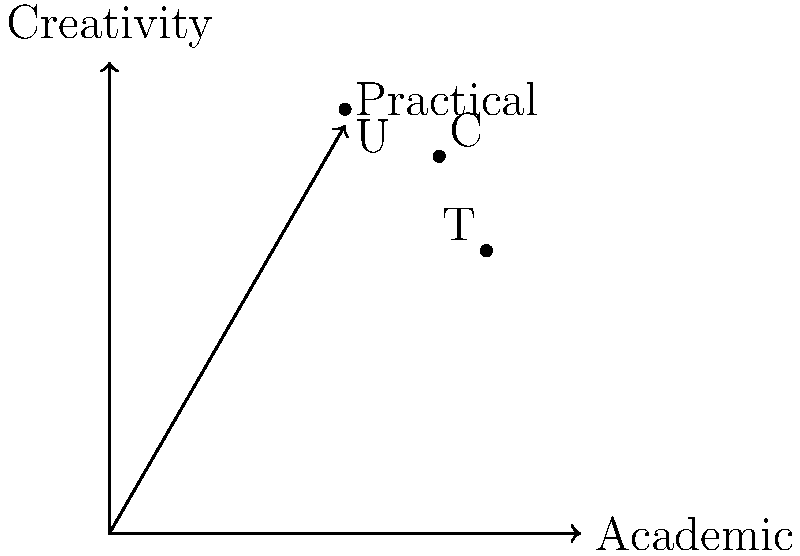In the context of analyzing learning styles and career outcomes, consider the following vectors representing different educational approaches and career requirements:

Traditional Education: $\mathbf{T} = (0.8, 0.6, 0.4)$
Unschooling: $\mathbf{U} = (0.5, 0.9, 0.7)$
Career Requirements: $\mathbf{C} = (0.7, 0.8, 0.6)$

The components represent scores in Academic, Creativity, and Practical skills respectively. Calculate the dot product of the Unschooling vector with the Career Requirements vector, and interpret what this result suggests about the alignment of unschooling with career needs. To solve this problem, we'll follow these steps:

1) Recall the formula for the dot product of two vectors:
   $\mathbf{A} \cdot \mathbf{B} = A_1B_1 + A_2B_2 + A_3B_3$

2) For Unschooling $\mathbf{U} = (0.5, 0.9, 0.7)$ and Career Requirements $\mathbf{C} = (0.7, 0.8, 0.6)$

3) Calculate the dot product:
   $\mathbf{U} \cdot \mathbf{C} = (0.5)(0.7) + (0.9)(0.8) + (0.7)(0.6)$
   $= 0.35 + 0.72 + 0.42$
   $= 1.49$

4) Interpret the result:
   - The dot product is positive, indicating that unschooling and career requirements are generally aligned.
   - The maximum possible dot product for unit vectors would be 1, so 1.49 suggests a strong alignment.
   - This high value indicates that unschooling's emphasis on creativity and practical skills aligns well with career needs, while still providing sufficient academic preparation.

5) For comparison, we could calculate the dot product of Traditional Education with Career Requirements:
   $\mathbf{T} \cdot \mathbf{C} = (0.8)(0.7) + (0.6)(0.8) + (0.4)(0.6) = 1.30$

   This is lower than the unschooling result, suggesting that unschooling might better prepare students for the given career requirements.
Answer: 1.49; strong alignment between unschooling and career requirements 